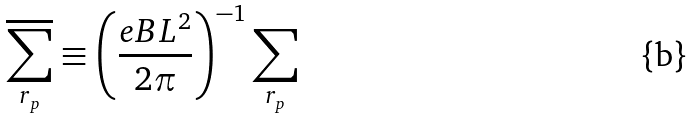<formula> <loc_0><loc_0><loc_500><loc_500>\overline { \sum _ { r _ { p } } } \equiv \left ( \frac { e B L ^ { 2 } } { 2 \pi } \right ) ^ { - 1 } \sum _ { r _ { p } }</formula> 